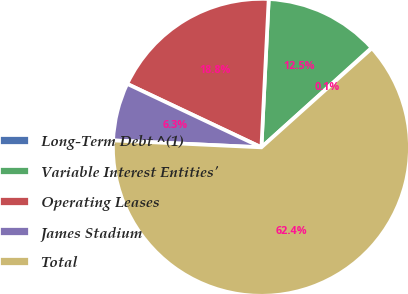Convert chart. <chart><loc_0><loc_0><loc_500><loc_500><pie_chart><fcel>Long-Term Debt ^(1)<fcel>Variable Interest Entities'<fcel>Operating Leases<fcel>James Stadium<fcel>Total<nl><fcel>0.06%<fcel>12.52%<fcel>18.75%<fcel>6.29%<fcel>62.37%<nl></chart> 